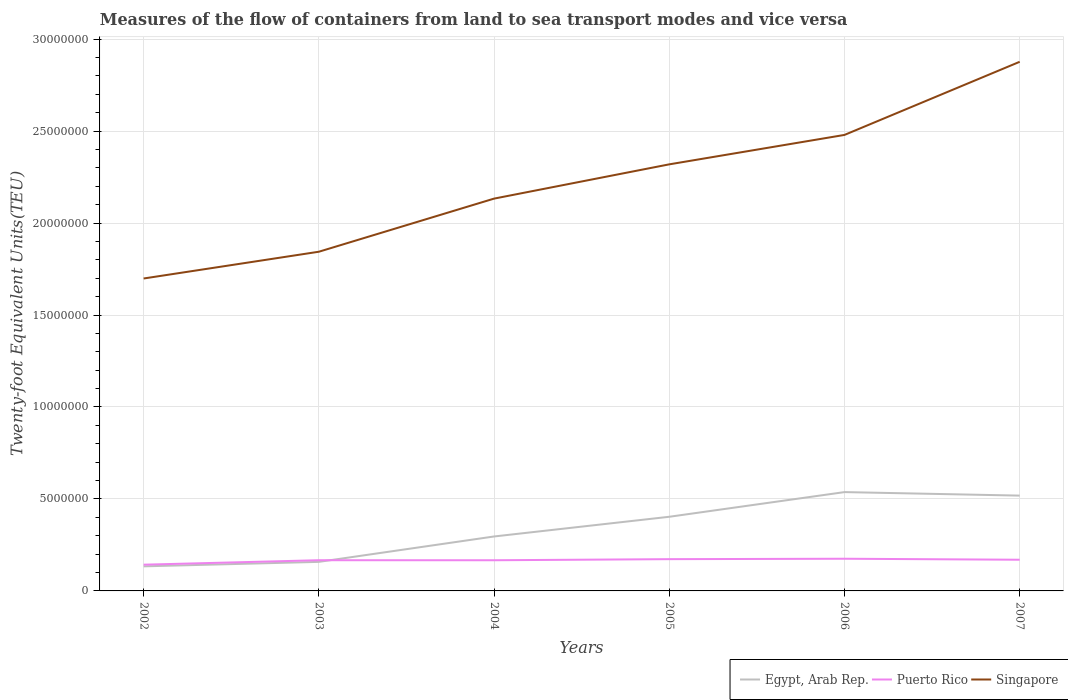How many different coloured lines are there?
Provide a succinct answer. 3. Across all years, what is the maximum container port traffic in Egypt, Arab Rep.?
Provide a succinct answer. 1.34e+06. What is the total container port traffic in Egypt, Arab Rep. in the graph?
Offer a terse response. -1.62e+06. What is the difference between the highest and the second highest container port traffic in Singapore?
Ensure brevity in your answer.  1.18e+07. Are the values on the major ticks of Y-axis written in scientific E-notation?
Your response must be concise. No. Does the graph contain any zero values?
Provide a short and direct response. No. Does the graph contain grids?
Give a very brief answer. Yes. Where does the legend appear in the graph?
Your answer should be compact. Bottom right. How many legend labels are there?
Your answer should be very brief. 3. How are the legend labels stacked?
Your answer should be very brief. Horizontal. What is the title of the graph?
Provide a short and direct response. Measures of the flow of containers from land to sea transport modes and vice versa. What is the label or title of the X-axis?
Offer a very short reply. Years. What is the label or title of the Y-axis?
Your answer should be compact. Twenty-foot Equivalent Units(TEU). What is the Twenty-foot Equivalent Units(TEU) in Egypt, Arab Rep. in 2002?
Provide a succinct answer. 1.34e+06. What is the Twenty-foot Equivalent Units(TEU) in Puerto Rico in 2002?
Your response must be concise. 1.43e+06. What is the Twenty-foot Equivalent Units(TEU) of Singapore in 2002?
Give a very brief answer. 1.70e+07. What is the Twenty-foot Equivalent Units(TEU) in Egypt, Arab Rep. in 2003?
Provide a succinct answer. 1.58e+06. What is the Twenty-foot Equivalent Units(TEU) in Puerto Rico in 2003?
Ensure brevity in your answer.  1.67e+06. What is the Twenty-foot Equivalent Units(TEU) in Singapore in 2003?
Ensure brevity in your answer.  1.84e+07. What is the Twenty-foot Equivalent Units(TEU) of Egypt, Arab Rep. in 2004?
Provide a short and direct response. 2.96e+06. What is the Twenty-foot Equivalent Units(TEU) of Puerto Rico in 2004?
Give a very brief answer. 1.67e+06. What is the Twenty-foot Equivalent Units(TEU) of Singapore in 2004?
Offer a terse response. 2.13e+07. What is the Twenty-foot Equivalent Units(TEU) in Egypt, Arab Rep. in 2005?
Your answer should be compact. 4.03e+06. What is the Twenty-foot Equivalent Units(TEU) of Puerto Rico in 2005?
Your answer should be compact. 1.73e+06. What is the Twenty-foot Equivalent Units(TEU) in Singapore in 2005?
Your answer should be very brief. 2.32e+07. What is the Twenty-foot Equivalent Units(TEU) in Egypt, Arab Rep. in 2006?
Your answer should be very brief. 5.37e+06. What is the Twenty-foot Equivalent Units(TEU) in Puerto Rico in 2006?
Offer a terse response. 1.75e+06. What is the Twenty-foot Equivalent Units(TEU) of Singapore in 2006?
Offer a terse response. 2.48e+07. What is the Twenty-foot Equivalent Units(TEU) in Egypt, Arab Rep. in 2007?
Offer a terse response. 5.18e+06. What is the Twenty-foot Equivalent Units(TEU) in Puerto Rico in 2007?
Provide a succinct answer. 1.70e+06. What is the Twenty-foot Equivalent Units(TEU) of Singapore in 2007?
Your answer should be very brief. 2.88e+07. Across all years, what is the maximum Twenty-foot Equivalent Units(TEU) of Egypt, Arab Rep.?
Offer a terse response. 5.37e+06. Across all years, what is the maximum Twenty-foot Equivalent Units(TEU) of Puerto Rico?
Offer a very short reply. 1.75e+06. Across all years, what is the maximum Twenty-foot Equivalent Units(TEU) of Singapore?
Ensure brevity in your answer.  2.88e+07. Across all years, what is the minimum Twenty-foot Equivalent Units(TEU) in Egypt, Arab Rep.?
Keep it short and to the point. 1.34e+06. Across all years, what is the minimum Twenty-foot Equivalent Units(TEU) of Puerto Rico?
Ensure brevity in your answer.  1.43e+06. Across all years, what is the minimum Twenty-foot Equivalent Units(TEU) of Singapore?
Give a very brief answer. 1.70e+07. What is the total Twenty-foot Equivalent Units(TEU) in Egypt, Arab Rep. in the graph?
Give a very brief answer. 2.05e+07. What is the total Twenty-foot Equivalent Units(TEU) of Puerto Rico in the graph?
Offer a terse response. 9.94e+06. What is the total Twenty-foot Equivalent Units(TEU) of Singapore in the graph?
Your answer should be compact. 1.34e+08. What is the difference between the Twenty-foot Equivalent Units(TEU) of Egypt, Arab Rep. in 2002 and that in 2003?
Offer a terse response. -2.43e+05. What is the difference between the Twenty-foot Equivalent Units(TEU) of Puerto Rico in 2002 and that in 2003?
Make the answer very short. -2.43e+05. What is the difference between the Twenty-foot Equivalent Units(TEU) in Singapore in 2002 and that in 2003?
Give a very brief answer. -1.45e+06. What is the difference between the Twenty-foot Equivalent Units(TEU) of Egypt, Arab Rep. in 2002 and that in 2004?
Your answer should be very brief. -1.62e+06. What is the difference between the Twenty-foot Equivalent Units(TEU) in Puerto Rico in 2002 and that in 2004?
Your response must be concise. -2.42e+05. What is the difference between the Twenty-foot Equivalent Units(TEU) of Singapore in 2002 and that in 2004?
Ensure brevity in your answer.  -4.34e+06. What is the difference between the Twenty-foot Equivalent Units(TEU) in Egypt, Arab Rep. in 2002 and that in 2005?
Your answer should be compact. -2.70e+06. What is the difference between the Twenty-foot Equivalent Units(TEU) of Puerto Rico in 2002 and that in 2005?
Your response must be concise. -3.01e+05. What is the difference between the Twenty-foot Equivalent Units(TEU) of Singapore in 2002 and that in 2005?
Ensure brevity in your answer.  -6.21e+06. What is the difference between the Twenty-foot Equivalent Units(TEU) of Egypt, Arab Rep. in 2002 and that in 2006?
Offer a very short reply. -4.04e+06. What is the difference between the Twenty-foot Equivalent Units(TEU) in Puerto Rico in 2002 and that in 2006?
Give a very brief answer. -3.23e+05. What is the difference between the Twenty-foot Equivalent Units(TEU) in Singapore in 2002 and that in 2006?
Offer a terse response. -7.81e+06. What is the difference between the Twenty-foot Equivalent Units(TEU) of Egypt, Arab Rep. in 2002 and that in 2007?
Keep it short and to the point. -3.85e+06. What is the difference between the Twenty-foot Equivalent Units(TEU) in Puerto Rico in 2002 and that in 2007?
Offer a very short reply. -2.69e+05. What is the difference between the Twenty-foot Equivalent Units(TEU) in Singapore in 2002 and that in 2007?
Offer a terse response. -1.18e+07. What is the difference between the Twenty-foot Equivalent Units(TEU) in Egypt, Arab Rep. in 2003 and that in 2004?
Ensure brevity in your answer.  -1.38e+06. What is the difference between the Twenty-foot Equivalent Units(TEU) in Puerto Rico in 2003 and that in 2004?
Keep it short and to the point. 1302. What is the difference between the Twenty-foot Equivalent Units(TEU) of Singapore in 2003 and that in 2004?
Provide a succinct answer. -2.89e+06. What is the difference between the Twenty-foot Equivalent Units(TEU) in Egypt, Arab Rep. in 2003 and that in 2005?
Provide a succinct answer. -2.45e+06. What is the difference between the Twenty-foot Equivalent Units(TEU) in Puerto Rico in 2003 and that in 2005?
Offer a very short reply. -5.82e+04. What is the difference between the Twenty-foot Equivalent Units(TEU) of Singapore in 2003 and that in 2005?
Your answer should be very brief. -4.75e+06. What is the difference between the Twenty-foot Equivalent Units(TEU) of Egypt, Arab Rep. in 2003 and that in 2006?
Ensure brevity in your answer.  -3.79e+06. What is the difference between the Twenty-foot Equivalent Units(TEU) in Puerto Rico in 2003 and that in 2006?
Provide a succinct answer. -8.04e+04. What is the difference between the Twenty-foot Equivalent Units(TEU) of Singapore in 2003 and that in 2006?
Ensure brevity in your answer.  -6.35e+06. What is the difference between the Twenty-foot Equivalent Units(TEU) in Egypt, Arab Rep. in 2003 and that in 2007?
Offer a very short reply. -3.60e+06. What is the difference between the Twenty-foot Equivalent Units(TEU) of Puerto Rico in 2003 and that in 2007?
Provide a succinct answer. -2.61e+04. What is the difference between the Twenty-foot Equivalent Units(TEU) in Singapore in 2003 and that in 2007?
Your answer should be very brief. -1.03e+07. What is the difference between the Twenty-foot Equivalent Units(TEU) of Egypt, Arab Rep. in 2004 and that in 2005?
Offer a terse response. -1.07e+06. What is the difference between the Twenty-foot Equivalent Units(TEU) in Puerto Rico in 2004 and that in 2005?
Make the answer very short. -5.95e+04. What is the difference between the Twenty-foot Equivalent Units(TEU) in Singapore in 2004 and that in 2005?
Ensure brevity in your answer.  -1.86e+06. What is the difference between the Twenty-foot Equivalent Units(TEU) of Egypt, Arab Rep. in 2004 and that in 2006?
Provide a short and direct response. -2.41e+06. What is the difference between the Twenty-foot Equivalent Units(TEU) of Puerto Rico in 2004 and that in 2006?
Keep it short and to the point. -8.17e+04. What is the difference between the Twenty-foot Equivalent Units(TEU) of Singapore in 2004 and that in 2006?
Offer a very short reply. -3.46e+06. What is the difference between the Twenty-foot Equivalent Units(TEU) in Egypt, Arab Rep. in 2004 and that in 2007?
Give a very brief answer. -2.22e+06. What is the difference between the Twenty-foot Equivalent Units(TEU) in Puerto Rico in 2004 and that in 2007?
Your answer should be very brief. -2.74e+04. What is the difference between the Twenty-foot Equivalent Units(TEU) of Singapore in 2004 and that in 2007?
Provide a short and direct response. -7.44e+06. What is the difference between the Twenty-foot Equivalent Units(TEU) of Egypt, Arab Rep. in 2005 and that in 2006?
Make the answer very short. -1.34e+06. What is the difference between the Twenty-foot Equivalent Units(TEU) of Puerto Rico in 2005 and that in 2006?
Your response must be concise. -2.22e+04. What is the difference between the Twenty-foot Equivalent Units(TEU) in Singapore in 2005 and that in 2006?
Make the answer very short. -1.60e+06. What is the difference between the Twenty-foot Equivalent Units(TEU) of Egypt, Arab Rep. in 2005 and that in 2007?
Your answer should be compact. -1.15e+06. What is the difference between the Twenty-foot Equivalent Units(TEU) of Puerto Rico in 2005 and that in 2007?
Keep it short and to the point. 3.21e+04. What is the difference between the Twenty-foot Equivalent Units(TEU) in Singapore in 2005 and that in 2007?
Make the answer very short. -5.58e+06. What is the difference between the Twenty-foot Equivalent Units(TEU) of Egypt, Arab Rep. in 2006 and that in 2007?
Your response must be concise. 1.91e+05. What is the difference between the Twenty-foot Equivalent Units(TEU) in Puerto Rico in 2006 and that in 2007?
Provide a short and direct response. 5.43e+04. What is the difference between the Twenty-foot Equivalent Units(TEU) in Singapore in 2006 and that in 2007?
Your answer should be very brief. -3.98e+06. What is the difference between the Twenty-foot Equivalent Units(TEU) of Egypt, Arab Rep. in 2002 and the Twenty-foot Equivalent Units(TEU) of Puerto Rico in 2003?
Your response must be concise. -3.33e+05. What is the difference between the Twenty-foot Equivalent Units(TEU) of Egypt, Arab Rep. in 2002 and the Twenty-foot Equivalent Units(TEU) of Singapore in 2003?
Your answer should be very brief. -1.71e+07. What is the difference between the Twenty-foot Equivalent Units(TEU) in Puerto Rico in 2002 and the Twenty-foot Equivalent Units(TEU) in Singapore in 2003?
Give a very brief answer. -1.70e+07. What is the difference between the Twenty-foot Equivalent Units(TEU) in Egypt, Arab Rep. in 2002 and the Twenty-foot Equivalent Units(TEU) in Puerto Rico in 2004?
Your response must be concise. -3.32e+05. What is the difference between the Twenty-foot Equivalent Units(TEU) in Egypt, Arab Rep. in 2002 and the Twenty-foot Equivalent Units(TEU) in Singapore in 2004?
Give a very brief answer. -2.00e+07. What is the difference between the Twenty-foot Equivalent Units(TEU) of Puerto Rico in 2002 and the Twenty-foot Equivalent Units(TEU) of Singapore in 2004?
Provide a short and direct response. -1.99e+07. What is the difference between the Twenty-foot Equivalent Units(TEU) of Egypt, Arab Rep. in 2002 and the Twenty-foot Equivalent Units(TEU) of Puerto Rico in 2005?
Your answer should be compact. -3.91e+05. What is the difference between the Twenty-foot Equivalent Units(TEU) in Egypt, Arab Rep. in 2002 and the Twenty-foot Equivalent Units(TEU) in Singapore in 2005?
Keep it short and to the point. -2.19e+07. What is the difference between the Twenty-foot Equivalent Units(TEU) in Puerto Rico in 2002 and the Twenty-foot Equivalent Units(TEU) in Singapore in 2005?
Your answer should be very brief. -2.18e+07. What is the difference between the Twenty-foot Equivalent Units(TEU) in Egypt, Arab Rep. in 2002 and the Twenty-foot Equivalent Units(TEU) in Puerto Rico in 2006?
Your answer should be compact. -4.14e+05. What is the difference between the Twenty-foot Equivalent Units(TEU) in Egypt, Arab Rep. in 2002 and the Twenty-foot Equivalent Units(TEU) in Singapore in 2006?
Your response must be concise. -2.35e+07. What is the difference between the Twenty-foot Equivalent Units(TEU) in Puerto Rico in 2002 and the Twenty-foot Equivalent Units(TEU) in Singapore in 2006?
Provide a succinct answer. -2.34e+07. What is the difference between the Twenty-foot Equivalent Units(TEU) of Egypt, Arab Rep. in 2002 and the Twenty-foot Equivalent Units(TEU) of Puerto Rico in 2007?
Offer a terse response. -3.59e+05. What is the difference between the Twenty-foot Equivalent Units(TEU) in Egypt, Arab Rep. in 2002 and the Twenty-foot Equivalent Units(TEU) in Singapore in 2007?
Make the answer very short. -2.74e+07. What is the difference between the Twenty-foot Equivalent Units(TEU) of Puerto Rico in 2002 and the Twenty-foot Equivalent Units(TEU) of Singapore in 2007?
Your response must be concise. -2.73e+07. What is the difference between the Twenty-foot Equivalent Units(TEU) of Egypt, Arab Rep. in 2003 and the Twenty-foot Equivalent Units(TEU) of Puerto Rico in 2004?
Provide a short and direct response. -8.83e+04. What is the difference between the Twenty-foot Equivalent Units(TEU) of Egypt, Arab Rep. in 2003 and the Twenty-foot Equivalent Units(TEU) of Singapore in 2004?
Your answer should be compact. -1.97e+07. What is the difference between the Twenty-foot Equivalent Units(TEU) of Puerto Rico in 2003 and the Twenty-foot Equivalent Units(TEU) of Singapore in 2004?
Make the answer very short. -1.97e+07. What is the difference between the Twenty-foot Equivalent Units(TEU) in Egypt, Arab Rep. in 2003 and the Twenty-foot Equivalent Units(TEU) in Puerto Rico in 2005?
Ensure brevity in your answer.  -1.48e+05. What is the difference between the Twenty-foot Equivalent Units(TEU) of Egypt, Arab Rep. in 2003 and the Twenty-foot Equivalent Units(TEU) of Singapore in 2005?
Offer a terse response. -2.16e+07. What is the difference between the Twenty-foot Equivalent Units(TEU) of Puerto Rico in 2003 and the Twenty-foot Equivalent Units(TEU) of Singapore in 2005?
Keep it short and to the point. -2.15e+07. What is the difference between the Twenty-foot Equivalent Units(TEU) in Egypt, Arab Rep. in 2003 and the Twenty-foot Equivalent Units(TEU) in Puerto Rico in 2006?
Your answer should be very brief. -1.70e+05. What is the difference between the Twenty-foot Equivalent Units(TEU) of Egypt, Arab Rep. in 2003 and the Twenty-foot Equivalent Units(TEU) of Singapore in 2006?
Ensure brevity in your answer.  -2.32e+07. What is the difference between the Twenty-foot Equivalent Units(TEU) of Puerto Rico in 2003 and the Twenty-foot Equivalent Units(TEU) of Singapore in 2006?
Make the answer very short. -2.31e+07. What is the difference between the Twenty-foot Equivalent Units(TEU) in Egypt, Arab Rep. in 2003 and the Twenty-foot Equivalent Units(TEU) in Puerto Rico in 2007?
Your response must be concise. -1.16e+05. What is the difference between the Twenty-foot Equivalent Units(TEU) in Egypt, Arab Rep. in 2003 and the Twenty-foot Equivalent Units(TEU) in Singapore in 2007?
Ensure brevity in your answer.  -2.72e+07. What is the difference between the Twenty-foot Equivalent Units(TEU) in Puerto Rico in 2003 and the Twenty-foot Equivalent Units(TEU) in Singapore in 2007?
Provide a short and direct response. -2.71e+07. What is the difference between the Twenty-foot Equivalent Units(TEU) in Egypt, Arab Rep. in 2004 and the Twenty-foot Equivalent Units(TEU) in Puerto Rico in 2005?
Make the answer very short. 1.23e+06. What is the difference between the Twenty-foot Equivalent Units(TEU) of Egypt, Arab Rep. in 2004 and the Twenty-foot Equivalent Units(TEU) of Singapore in 2005?
Give a very brief answer. -2.02e+07. What is the difference between the Twenty-foot Equivalent Units(TEU) in Puerto Rico in 2004 and the Twenty-foot Equivalent Units(TEU) in Singapore in 2005?
Ensure brevity in your answer.  -2.15e+07. What is the difference between the Twenty-foot Equivalent Units(TEU) of Egypt, Arab Rep. in 2004 and the Twenty-foot Equivalent Units(TEU) of Puerto Rico in 2006?
Offer a very short reply. 1.21e+06. What is the difference between the Twenty-foot Equivalent Units(TEU) in Egypt, Arab Rep. in 2004 and the Twenty-foot Equivalent Units(TEU) in Singapore in 2006?
Provide a short and direct response. -2.18e+07. What is the difference between the Twenty-foot Equivalent Units(TEU) of Puerto Rico in 2004 and the Twenty-foot Equivalent Units(TEU) of Singapore in 2006?
Provide a short and direct response. -2.31e+07. What is the difference between the Twenty-foot Equivalent Units(TEU) in Egypt, Arab Rep. in 2004 and the Twenty-foot Equivalent Units(TEU) in Puerto Rico in 2007?
Give a very brief answer. 1.26e+06. What is the difference between the Twenty-foot Equivalent Units(TEU) in Egypt, Arab Rep. in 2004 and the Twenty-foot Equivalent Units(TEU) in Singapore in 2007?
Offer a terse response. -2.58e+07. What is the difference between the Twenty-foot Equivalent Units(TEU) in Puerto Rico in 2004 and the Twenty-foot Equivalent Units(TEU) in Singapore in 2007?
Ensure brevity in your answer.  -2.71e+07. What is the difference between the Twenty-foot Equivalent Units(TEU) of Egypt, Arab Rep. in 2005 and the Twenty-foot Equivalent Units(TEU) of Puerto Rico in 2006?
Keep it short and to the point. 2.28e+06. What is the difference between the Twenty-foot Equivalent Units(TEU) in Egypt, Arab Rep. in 2005 and the Twenty-foot Equivalent Units(TEU) in Singapore in 2006?
Give a very brief answer. -2.08e+07. What is the difference between the Twenty-foot Equivalent Units(TEU) of Puerto Rico in 2005 and the Twenty-foot Equivalent Units(TEU) of Singapore in 2006?
Give a very brief answer. -2.31e+07. What is the difference between the Twenty-foot Equivalent Units(TEU) of Egypt, Arab Rep. in 2005 and the Twenty-foot Equivalent Units(TEU) of Puerto Rico in 2007?
Your answer should be compact. 2.34e+06. What is the difference between the Twenty-foot Equivalent Units(TEU) of Egypt, Arab Rep. in 2005 and the Twenty-foot Equivalent Units(TEU) of Singapore in 2007?
Provide a short and direct response. -2.47e+07. What is the difference between the Twenty-foot Equivalent Units(TEU) in Puerto Rico in 2005 and the Twenty-foot Equivalent Units(TEU) in Singapore in 2007?
Keep it short and to the point. -2.70e+07. What is the difference between the Twenty-foot Equivalent Units(TEU) in Egypt, Arab Rep. in 2006 and the Twenty-foot Equivalent Units(TEU) in Puerto Rico in 2007?
Provide a short and direct response. 3.68e+06. What is the difference between the Twenty-foot Equivalent Units(TEU) in Egypt, Arab Rep. in 2006 and the Twenty-foot Equivalent Units(TEU) in Singapore in 2007?
Offer a terse response. -2.34e+07. What is the difference between the Twenty-foot Equivalent Units(TEU) of Puerto Rico in 2006 and the Twenty-foot Equivalent Units(TEU) of Singapore in 2007?
Provide a succinct answer. -2.70e+07. What is the average Twenty-foot Equivalent Units(TEU) in Egypt, Arab Rep. per year?
Give a very brief answer. 3.41e+06. What is the average Twenty-foot Equivalent Units(TEU) in Puerto Rico per year?
Provide a succinct answer. 1.66e+06. What is the average Twenty-foot Equivalent Units(TEU) of Singapore per year?
Offer a terse response. 2.23e+07. In the year 2002, what is the difference between the Twenty-foot Equivalent Units(TEU) in Egypt, Arab Rep. and Twenty-foot Equivalent Units(TEU) in Puerto Rico?
Offer a very short reply. -9.02e+04. In the year 2002, what is the difference between the Twenty-foot Equivalent Units(TEU) of Egypt, Arab Rep. and Twenty-foot Equivalent Units(TEU) of Singapore?
Your answer should be compact. -1.56e+07. In the year 2002, what is the difference between the Twenty-foot Equivalent Units(TEU) of Puerto Rico and Twenty-foot Equivalent Units(TEU) of Singapore?
Your answer should be compact. -1.56e+07. In the year 2003, what is the difference between the Twenty-foot Equivalent Units(TEU) in Egypt, Arab Rep. and Twenty-foot Equivalent Units(TEU) in Puerto Rico?
Provide a short and direct response. -8.96e+04. In the year 2003, what is the difference between the Twenty-foot Equivalent Units(TEU) in Egypt, Arab Rep. and Twenty-foot Equivalent Units(TEU) in Singapore?
Offer a very short reply. -1.69e+07. In the year 2003, what is the difference between the Twenty-foot Equivalent Units(TEU) in Puerto Rico and Twenty-foot Equivalent Units(TEU) in Singapore?
Your answer should be very brief. -1.68e+07. In the year 2004, what is the difference between the Twenty-foot Equivalent Units(TEU) in Egypt, Arab Rep. and Twenty-foot Equivalent Units(TEU) in Puerto Rico?
Provide a short and direct response. 1.29e+06. In the year 2004, what is the difference between the Twenty-foot Equivalent Units(TEU) of Egypt, Arab Rep. and Twenty-foot Equivalent Units(TEU) of Singapore?
Give a very brief answer. -1.84e+07. In the year 2004, what is the difference between the Twenty-foot Equivalent Units(TEU) in Puerto Rico and Twenty-foot Equivalent Units(TEU) in Singapore?
Your answer should be compact. -1.97e+07. In the year 2005, what is the difference between the Twenty-foot Equivalent Units(TEU) in Egypt, Arab Rep. and Twenty-foot Equivalent Units(TEU) in Puerto Rico?
Your response must be concise. 2.30e+06. In the year 2005, what is the difference between the Twenty-foot Equivalent Units(TEU) in Egypt, Arab Rep. and Twenty-foot Equivalent Units(TEU) in Singapore?
Your response must be concise. -1.92e+07. In the year 2005, what is the difference between the Twenty-foot Equivalent Units(TEU) in Puerto Rico and Twenty-foot Equivalent Units(TEU) in Singapore?
Your answer should be compact. -2.15e+07. In the year 2006, what is the difference between the Twenty-foot Equivalent Units(TEU) in Egypt, Arab Rep. and Twenty-foot Equivalent Units(TEU) in Puerto Rico?
Provide a short and direct response. 3.62e+06. In the year 2006, what is the difference between the Twenty-foot Equivalent Units(TEU) of Egypt, Arab Rep. and Twenty-foot Equivalent Units(TEU) of Singapore?
Keep it short and to the point. -1.94e+07. In the year 2006, what is the difference between the Twenty-foot Equivalent Units(TEU) of Puerto Rico and Twenty-foot Equivalent Units(TEU) of Singapore?
Offer a very short reply. -2.30e+07. In the year 2007, what is the difference between the Twenty-foot Equivalent Units(TEU) in Egypt, Arab Rep. and Twenty-foot Equivalent Units(TEU) in Puerto Rico?
Your response must be concise. 3.49e+06. In the year 2007, what is the difference between the Twenty-foot Equivalent Units(TEU) in Egypt, Arab Rep. and Twenty-foot Equivalent Units(TEU) in Singapore?
Your answer should be very brief. -2.36e+07. In the year 2007, what is the difference between the Twenty-foot Equivalent Units(TEU) in Puerto Rico and Twenty-foot Equivalent Units(TEU) in Singapore?
Offer a terse response. -2.71e+07. What is the ratio of the Twenty-foot Equivalent Units(TEU) of Egypt, Arab Rep. in 2002 to that in 2003?
Provide a succinct answer. 0.85. What is the ratio of the Twenty-foot Equivalent Units(TEU) of Puerto Rico in 2002 to that in 2003?
Your answer should be very brief. 0.85. What is the ratio of the Twenty-foot Equivalent Units(TEU) in Singapore in 2002 to that in 2003?
Your answer should be very brief. 0.92. What is the ratio of the Twenty-foot Equivalent Units(TEU) of Egypt, Arab Rep. in 2002 to that in 2004?
Your response must be concise. 0.45. What is the ratio of the Twenty-foot Equivalent Units(TEU) of Puerto Rico in 2002 to that in 2004?
Provide a short and direct response. 0.86. What is the ratio of the Twenty-foot Equivalent Units(TEU) of Singapore in 2002 to that in 2004?
Give a very brief answer. 0.8. What is the ratio of the Twenty-foot Equivalent Units(TEU) in Egypt, Arab Rep. in 2002 to that in 2005?
Ensure brevity in your answer.  0.33. What is the ratio of the Twenty-foot Equivalent Units(TEU) of Puerto Rico in 2002 to that in 2005?
Provide a succinct answer. 0.83. What is the ratio of the Twenty-foot Equivalent Units(TEU) of Singapore in 2002 to that in 2005?
Make the answer very short. 0.73. What is the ratio of the Twenty-foot Equivalent Units(TEU) of Egypt, Arab Rep. in 2002 to that in 2006?
Your response must be concise. 0.25. What is the ratio of the Twenty-foot Equivalent Units(TEU) of Puerto Rico in 2002 to that in 2006?
Your answer should be compact. 0.82. What is the ratio of the Twenty-foot Equivalent Units(TEU) in Singapore in 2002 to that in 2006?
Your response must be concise. 0.69. What is the ratio of the Twenty-foot Equivalent Units(TEU) of Egypt, Arab Rep. in 2002 to that in 2007?
Give a very brief answer. 0.26. What is the ratio of the Twenty-foot Equivalent Units(TEU) of Puerto Rico in 2002 to that in 2007?
Give a very brief answer. 0.84. What is the ratio of the Twenty-foot Equivalent Units(TEU) of Singapore in 2002 to that in 2007?
Offer a very short reply. 0.59. What is the ratio of the Twenty-foot Equivalent Units(TEU) of Egypt, Arab Rep. in 2003 to that in 2004?
Your answer should be compact. 0.53. What is the ratio of the Twenty-foot Equivalent Units(TEU) in Puerto Rico in 2003 to that in 2004?
Provide a short and direct response. 1. What is the ratio of the Twenty-foot Equivalent Units(TEU) of Singapore in 2003 to that in 2004?
Your answer should be compact. 0.86. What is the ratio of the Twenty-foot Equivalent Units(TEU) in Egypt, Arab Rep. in 2003 to that in 2005?
Provide a succinct answer. 0.39. What is the ratio of the Twenty-foot Equivalent Units(TEU) in Puerto Rico in 2003 to that in 2005?
Your answer should be compact. 0.97. What is the ratio of the Twenty-foot Equivalent Units(TEU) of Singapore in 2003 to that in 2005?
Offer a terse response. 0.8. What is the ratio of the Twenty-foot Equivalent Units(TEU) of Egypt, Arab Rep. in 2003 to that in 2006?
Your answer should be compact. 0.29. What is the ratio of the Twenty-foot Equivalent Units(TEU) in Puerto Rico in 2003 to that in 2006?
Provide a short and direct response. 0.95. What is the ratio of the Twenty-foot Equivalent Units(TEU) of Singapore in 2003 to that in 2006?
Provide a short and direct response. 0.74. What is the ratio of the Twenty-foot Equivalent Units(TEU) in Egypt, Arab Rep. in 2003 to that in 2007?
Make the answer very short. 0.3. What is the ratio of the Twenty-foot Equivalent Units(TEU) of Puerto Rico in 2003 to that in 2007?
Give a very brief answer. 0.98. What is the ratio of the Twenty-foot Equivalent Units(TEU) of Singapore in 2003 to that in 2007?
Provide a short and direct response. 0.64. What is the ratio of the Twenty-foot Equivalent Units(TEU) of Egypt, Arab Rep. in 2004 to that in 2005?
Offer a terse response. 0.73. What is the ratio of the Twenty-foot Equivalent Units(TEU) in Puerto Rico in 2004 to that in 2005?
Your response must be concise. 0.97. What is the ratio of the Twenty-foot Equivalent Units(TEU) in Singapore in 2004 to that in 2005?
Your answer should be compact. 0.92. What is the ratio of the Twenty-foot Equivalent Units(TEU) in Egypt, Arab Rep. in 2004 to that in 2006?
Make the answer very short. 0.55. What is the ratio of the Twenty-foot Equivalent Units(TEU) of Puerto Rico in 2004 to that in 2006?
Give a very brief answer. 0.95. What is the ratio of the Twenty-foot Equivalent Units(TEU) in Singapore in 2004 to that in 2006?
Offer a terse response. 0.86. What is the ratio of the Twenty-foot Equivalent Units(TEU) of Egypt, Arab Rep. in 2004 to that in 2007?
Make the answer very short. 0.57. What is the ratio of the Twenty-foot Equivalent Units(TEU) in Puerto Rico in 2004 to that in 2007?
Provide a short and direct response. 0.98. What is the ratio of the Twenty-foot Equivalent Units(TEU) in Singapore in 2004 to that in 2007?
Provide a succinct answer. 0.74. What is the ratio of the Twenty-foot Equivalent Units(TEU) of Egypt, Arab Rep. in 2005 to that in 2006?
Make the answer very short. 0.75. What is the ratio of the Twenty-foot Equivalent Units(TEU) in Puerto Rico in 2005 to that in 2006?
Make the answer very short. 0.99. What is the ratio of the Twenty-foot Equivalent Units(TEU) of Singapore in 2005 to that in 2006?
Provide a short and direct response. 0.94. What is the ratio of the Twenty-foot Equivalent Units(TEU) of Egypt, Arab Rep. in 2005 to that in 2007?
Your answer should be very brief. 0.78. What is the ratio of the Twenty-foot Equivalent Units(TEU) of Puerto Rico in 2005 to that in 2007?
Offer a terse response. 1.02. What is the ratio of the Twenty-foot Equivalent Units(TEU) of Singapore in 2005 to that in 2007?
Offer a terse response. 0.81. What is the ratio of the Twenty-foot Equivalent Units(TEU) in Egypt, Arab Rep. in 2006 to that in 2007?
Provide a short and direct response. 1.04. What is the ratio of the Twenty-foot Equivalent Units(TEU) of Puerto Rico in 2006 to that in 2007?
Keep it short and to the point. 1.03. What is the ratio of the Twenty-foot Equivalent Units(TEU) of Singapore in 2006 to that in 2007?
Offer a very short reply. 0.86. What is the difference between the highest and the second highest Twenty-foot Equivalent Units(TEU) in Egypt, Arab Rep.?
Provide a short and direct response. 1.91e+05. What is the difference between the highest and the second highest Twenty-foot Equivalent Units(TEU) in Puerto Rico?
Make the answer very short. 2.22e+04. What is the difference between the highest and the second highest Twenty-foot Equivalent Units(TEU) in Singapore?
Give a very brief answer. 3.98e+06. What is the difference between the highest and the lowest Twenty-foot Equivalent Units(TEU) of Egypt, Arab Rep.?
Your response must be concise. 4.04e+06. What is the difference between the highest and the lowest Twenty-foot Equivalent Units(TEU) in Puerto Rico?
Your response must be concise. 3.23e+05. What is the difference between the highest and the lowest Twenty-foot Equivalent Units(TEU) of Singapore?
Your response must be concise. 1.18e+07. 